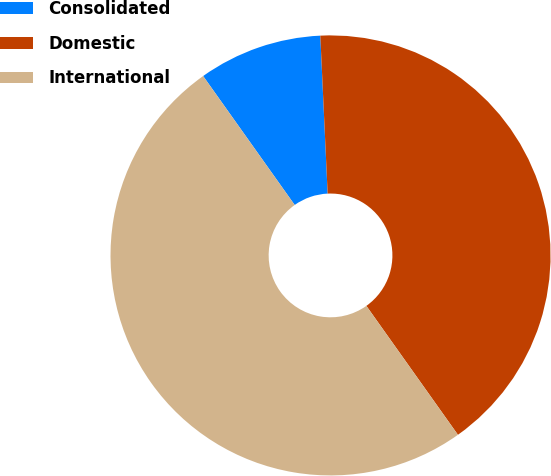<chart> <loc_0><loc_0><loc_500><loc_500><pie_chart><fcel>Consolidated<fcel>Domestic<fcel>International<nl><fcel>9.09%<fcel>40.91%<fcel>50.0%<nl></chart> 